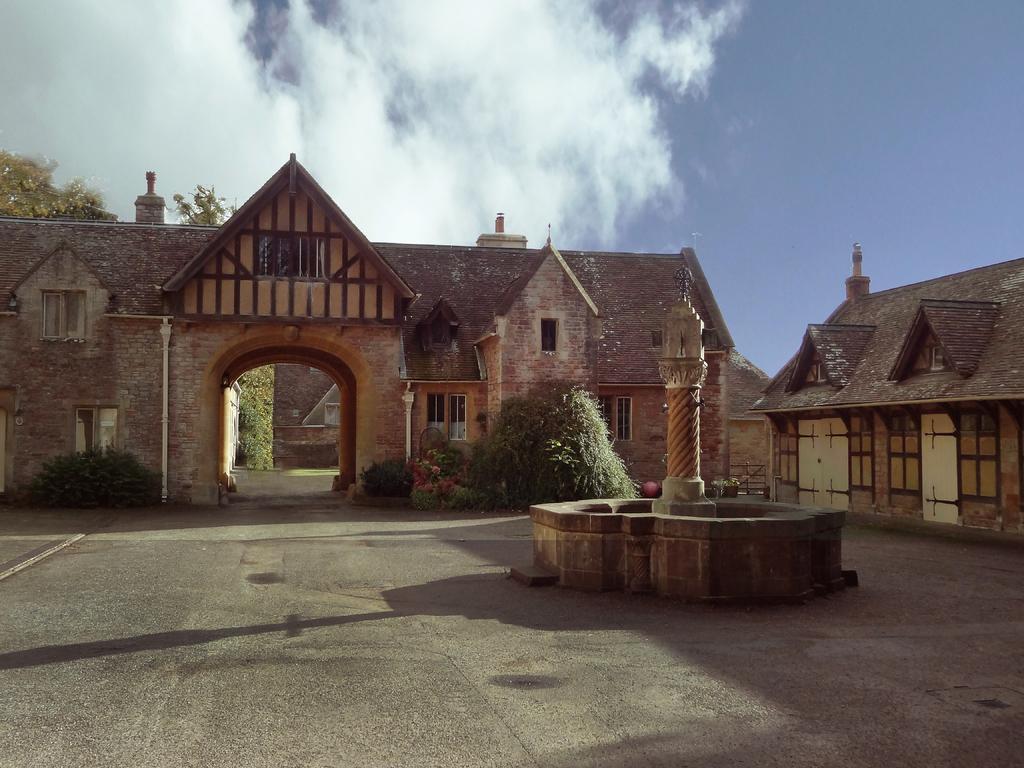Describe this image in one or two sentences. In this picture in the center there is a pillar and there is a wall. In the background there are houses, plants and trees and the sky is cloudy. 